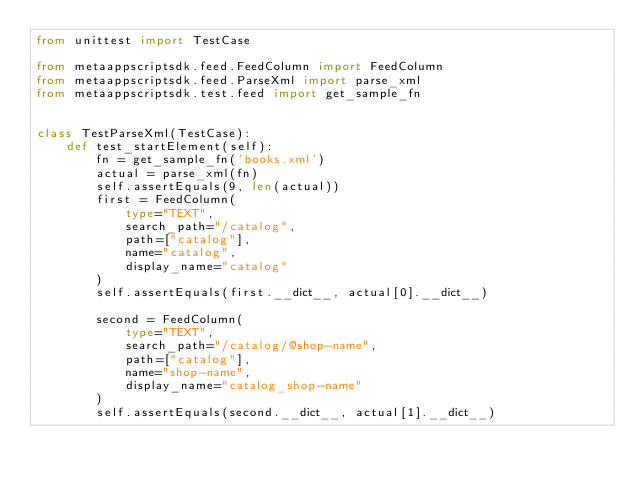Convert code to text. <code><loc_0><loc_0><loc_500><loc_500><_Python_>from unittest import TestCase

from metaappscriptsdk.feed.FeedColumn import FeedColumn
from metaappscriptsdk.feed.ParseXml import parse_xml
from metaappscriptsdk.test.feed import get_sample_fn


class TestParseXml(TestCase):
    def test_startElement(self):
        fn = get_sample_fn('books.xml')
        actual = parse_xml(fn)
        self.assertEquals(9, len(actual))
        first = FeedColumn(
            type="TEXT",
            search_path="/catalog",
            path=["catalog"],
            name="catalog",
            display_name="catalog"
        )
        self.assertEquals(first.__dict__, actual[0].__dict__)

        second = FeedColumn(
            type="TEXT",
            search_path="/catalog/@shop-name",
            path=["catalog"],
            name="shop-name",
            display_name="catalog_shop-name"
        )
        self.assertEquals(second.__dict__, actual[1].__dict__)
</code> 